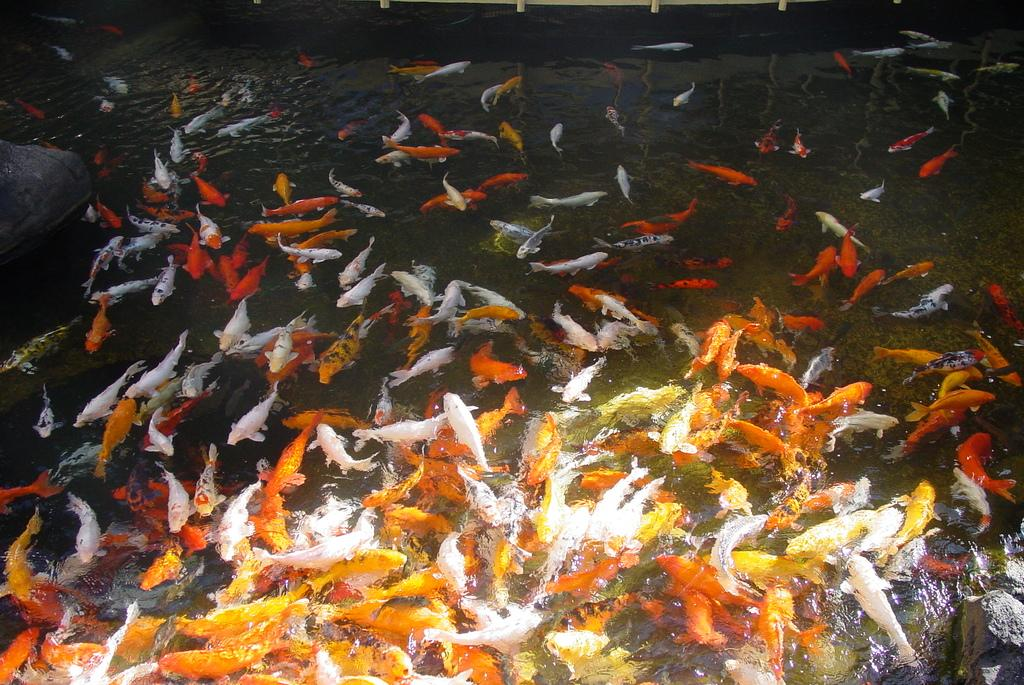What type of animals can be seen in the image? There is a group of fishes in the water. Can you describe the environment in which the animals are located? The fishes are in the water. How many fishes can be seen in the image? The number of fishes is not specified, but there is a group of them in the water. What type of yam can be seen floating in the water with the fishes? There is no yam present in the image; it features a group of fishes in the water, and no yam is visible. 